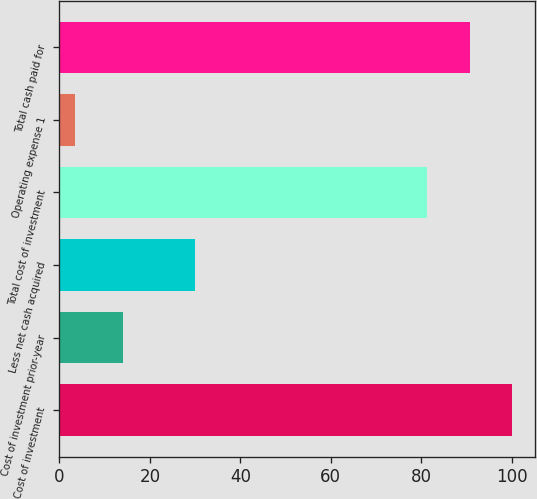<chart> <loc_0><loc_0><loc_500><loc_500><bar_chart><fcel>Cost of investment<fcel>Cost of investment prior-year<fcel>Less net cash acquired<fcel>Total cost of investment<fcel>Operating expense 1<fcel>Total cash paid for<nl><fcel>100.18<fcel>14<fcel>29.9<fcel>81.4<fcel>3.4<fcel>90.79<nl></chart> 